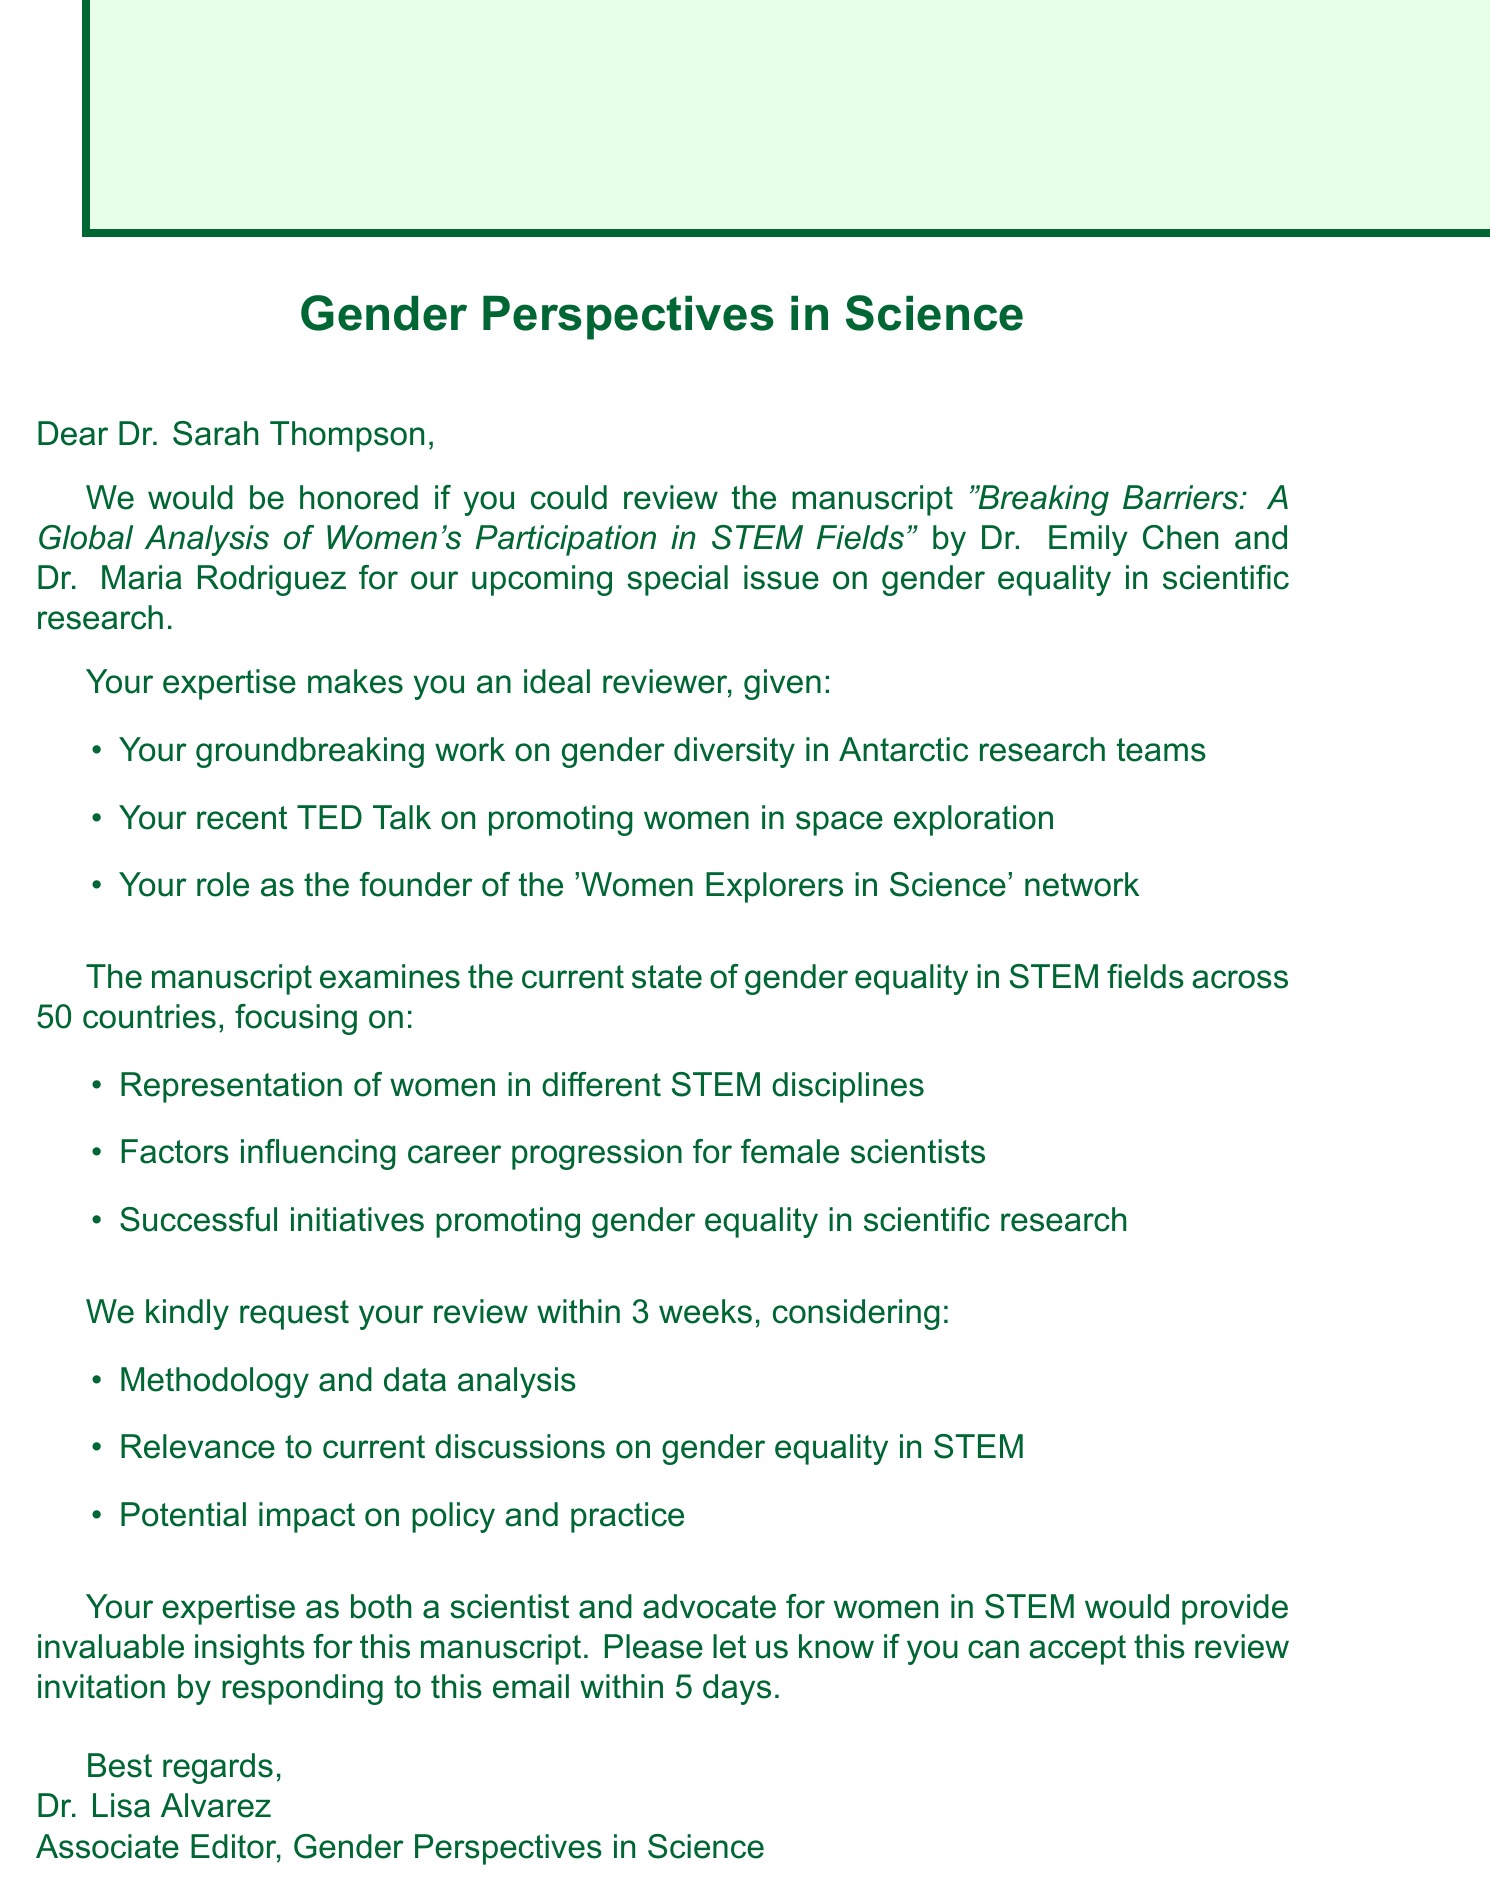What is the name of the journal? The journal's name is mentioned at the beginning of the document as "Gender Perspectives in Science."
Answer: Gender Perspectives in Science Who are the authors of the manuscript? The authors are identified in the introduction, specifically as "Dr. Emily Chen and Dr. Maria Rodriguez."
Answer: Dr. Emily Chen and Dr. Maria Rodriguez What is the main focus of the manuscript? The manuscript's main focus is described as examining the current state of gender equality in STEM fields across 50 countries.
Answer: Gender equality in STEM fields What is the deadline for the review request? The deadline for the review request is clearly stated as "within 3 weeks."
Answer: 3 weeks What are the key topics covered in the manuscript? The key topics are listed in bullet points, including "Factors influencing career progression for female scientists."
Answer: Factors influencing career progression for female scientists What should the reviewer consider when evaluating the manuscript? Reviewers are asked to consider aspects such as "Methodology and data analysis" when reviewing the manuscript.
Answer: Methodology and data analysis How long does the recipient have to respond to the review invitation? The document states that the recipient should respond "within 5 days" to the review invitation.
Answer: 5 days What is the title of the manuscript? The title of the manuscript is highlighted in the introduction as "Breaking Barriers: A Global Analysis of Women's Participation in STEM Fields."
Answer: Breaking Barriers: A Global Analysis of Women's Participation in STEM Fields 